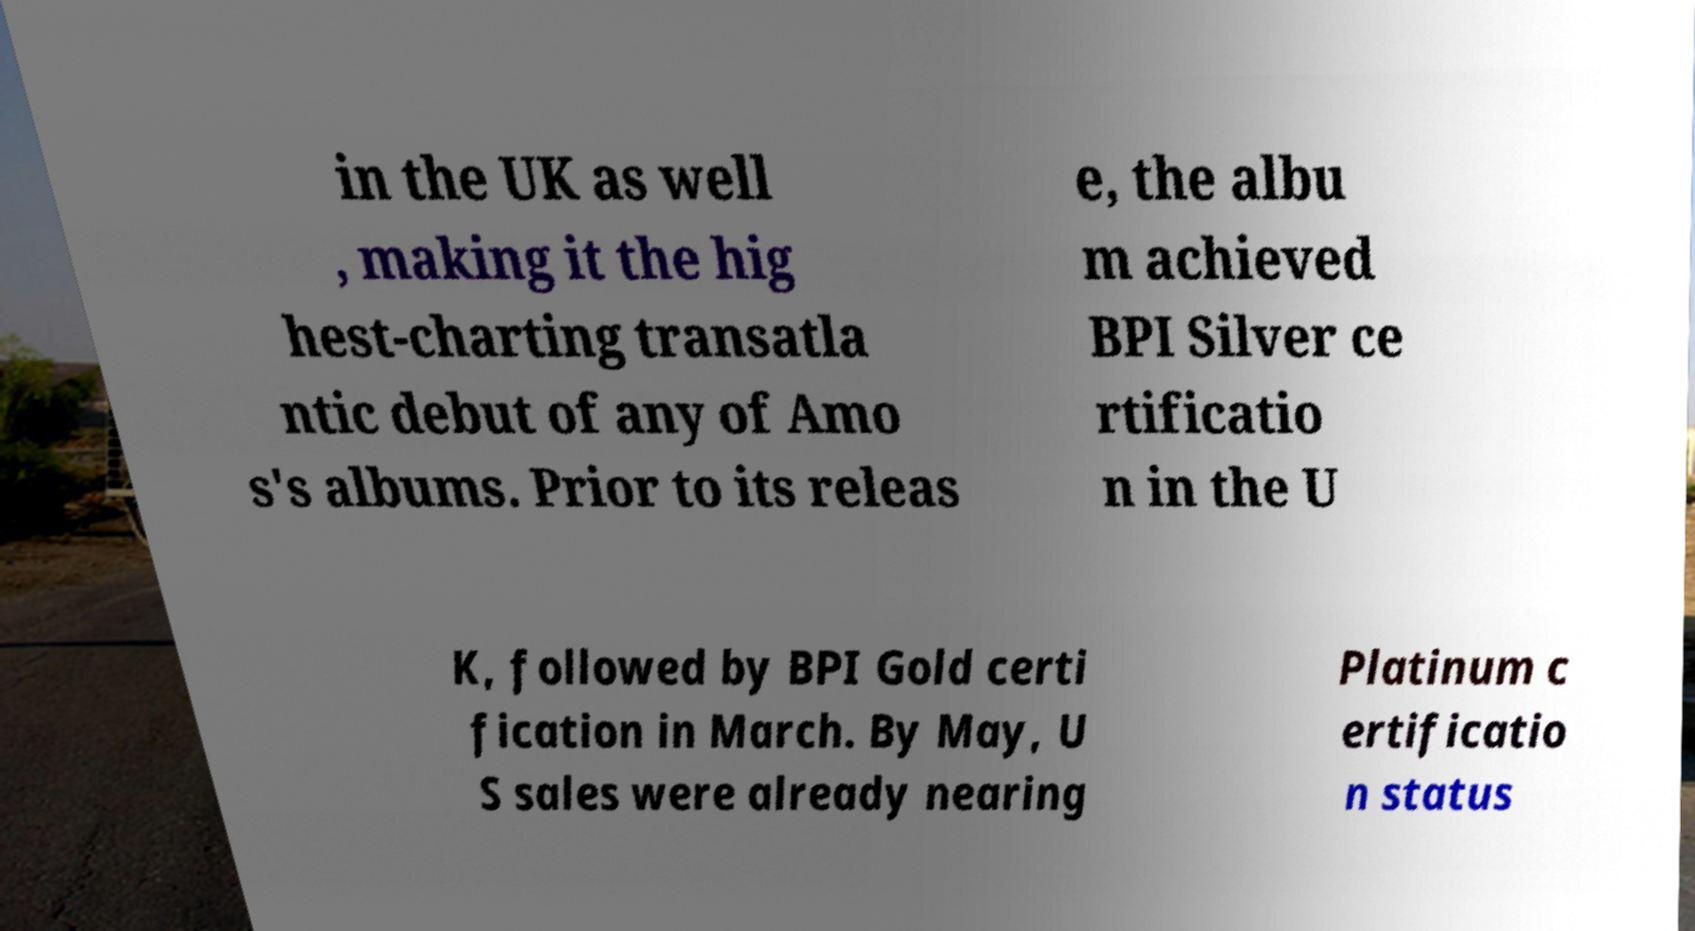Could you assist in decoding the text presented in this image and type it out clearly? in the UK as well , making it the hig hest-charting transatla ntic debut of any of Amo s's albums. Prior to its releas e, the albu m achieved BPI Silver ce rtificatio n in the U K, followed by BPI Gold certi fication in March. By May, U S sales were already nearing Platinum c ertificatio n status 